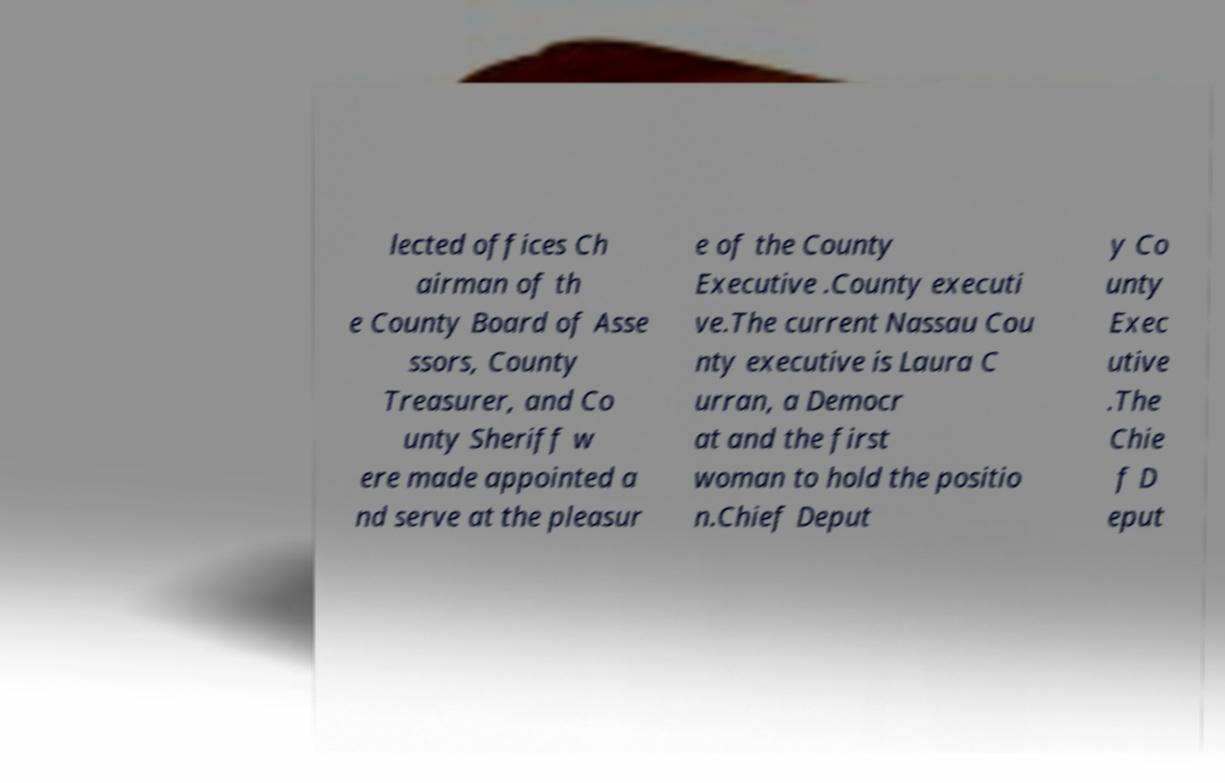Could you assist in decoding the text presented in this image and type it out clearly? lected offices Ch airman of th e County Board of Asse ssors, County Treasurer, and Co unty Sheriff w ere made appointed a nd serve at the pleasur e of the County Executive .County executi ve.The current Nassau Cou nty executive is Laura C urran, a Democr at and the first woman to hold the positio n.Chief Deput y Co unty Exec utive .The Chie f D eput 